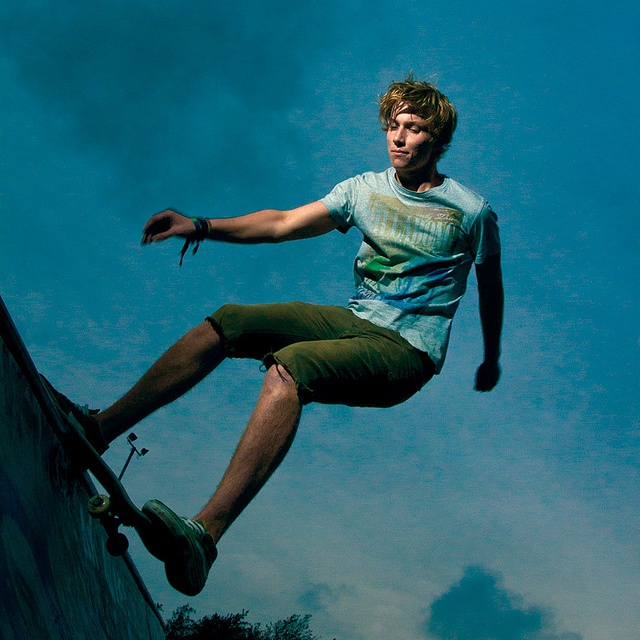Describe the objects in this image and their specific colors. I can see people in teal, black, gray, and maroon tones and skateboard in teal, black, and gray tones in this image. 